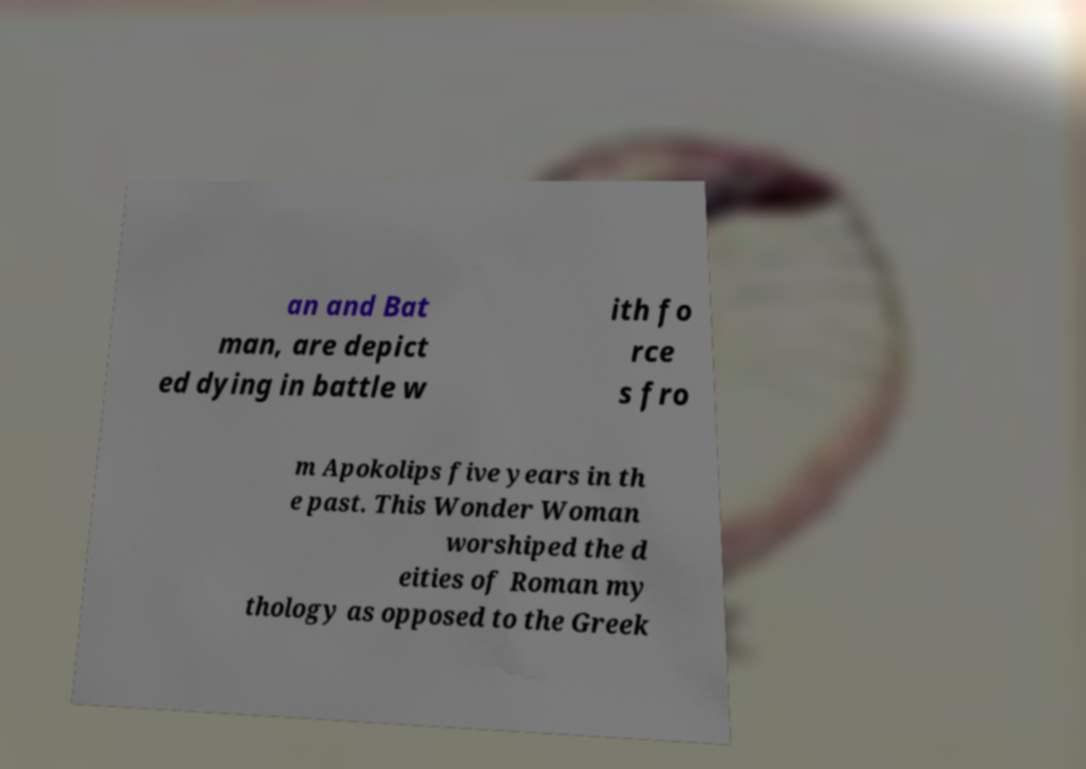What messages or text are displayed in this image? I need them in a readable, typed format. an and Bat man, are depict ed dying in battle w ith fo rce s fro m Apokolips five years in th e past. This Wonder Woman worshiped the d eities of Roman my thology as opposed to the Greek 